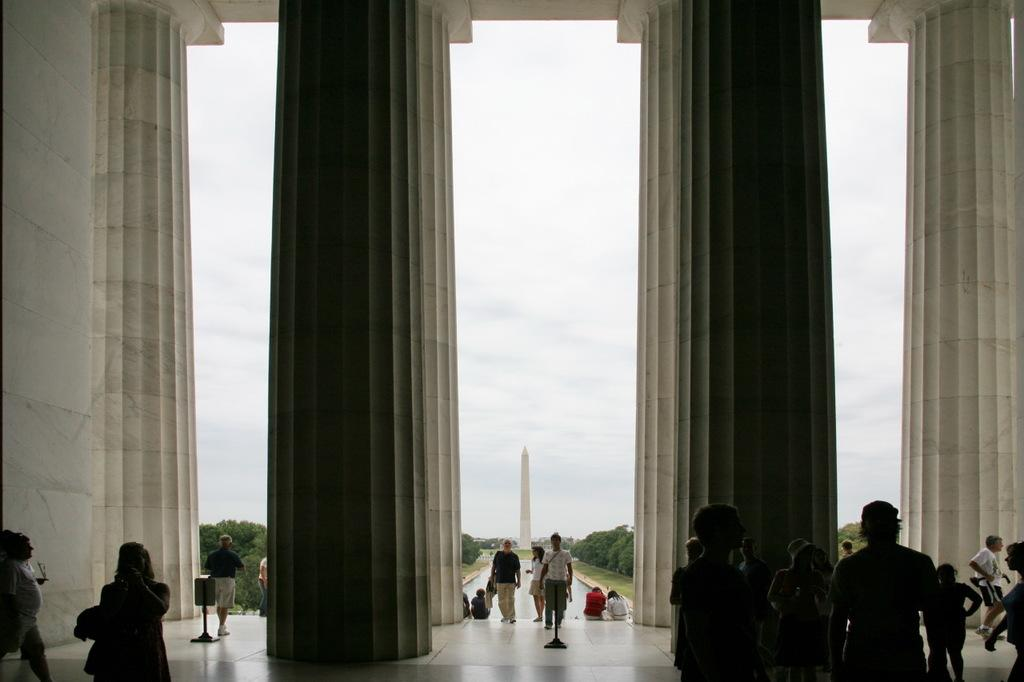What is happening at the bottom of the image? There are many people on the floor at the bottom of the image. How many pillars can be seen in the image? There are four pillars in the image. What can be seen in the background of the image? There are trees and a tower in the background of the image. What is visible at the top of the image? The sky is visible at the top of the image. What type of ink is being used to write on the receipt in the image? There is no receipt present in the image, so it is not possible to determine the type of ink being used. How is the division of labor being managed in the image? There is no indication of labor or division in the image; it primarily features people on the floor and pillars. 